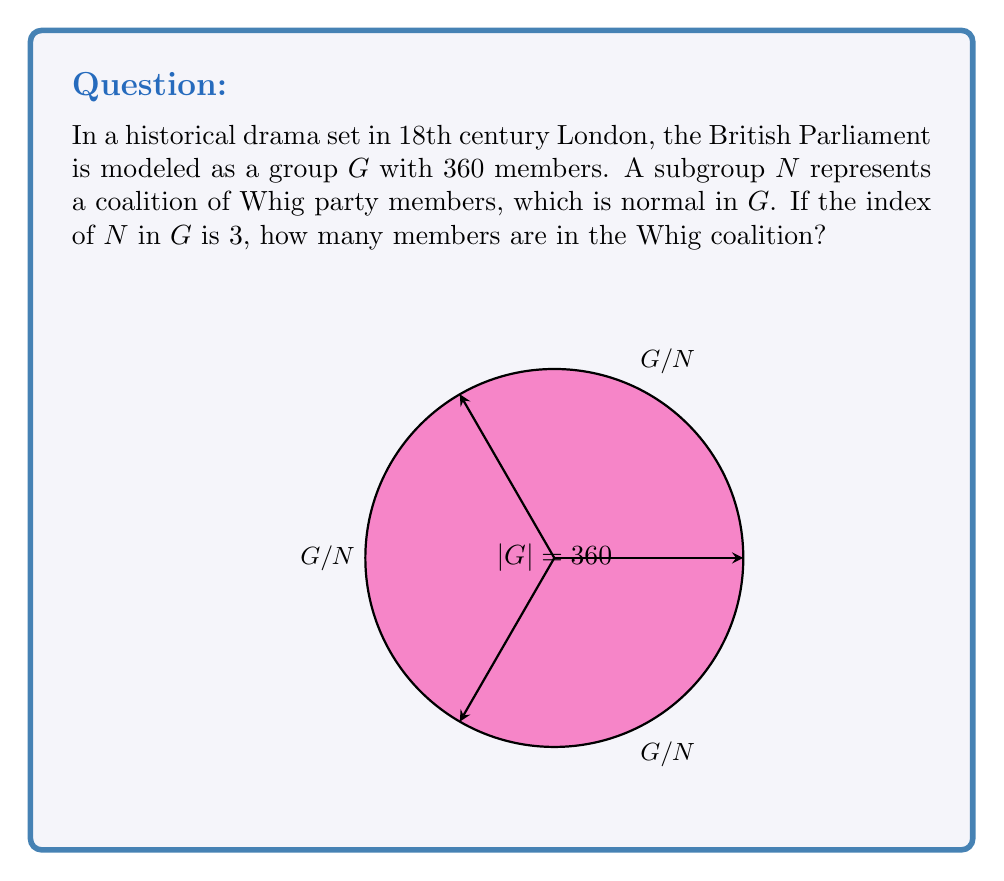Can you solve this math problem? Let's approach this step-by-step:

1) First, recall that for a subgroup $N$ of a group $G$, the index of $N$ in $G$ is defined as:

   $[G:N] = \frac{|G|}{|N|}$

   where $|G|$ and $|N|$ represent the orders (number of elements) of $G$ and $N$ respectively.

2) We are given that $[G:N] = 3$ and $|G| = 360$. Let's substitute these into the formula:

   $3 = \frac{360}{|N|}$

3) To solve for $|N|$, we multiply both sides by $|N|$:

   $3|N| = 360$

4) Then divide both sides by 3:

   $|N| = \frac{360}{3} = 120$

5) Therefore, the Whig coalition (represented by subgroup $N$) has 120 members.

This result aligns with the Lagrange's Theorem, which states that the order of a subgroup must divide the order of the group. Indeed, 120 divides 360 evenly.

The visualization in the question represents the three cosets of $N$ in $G$, corresponding to the index of 3.
Answer: 120 